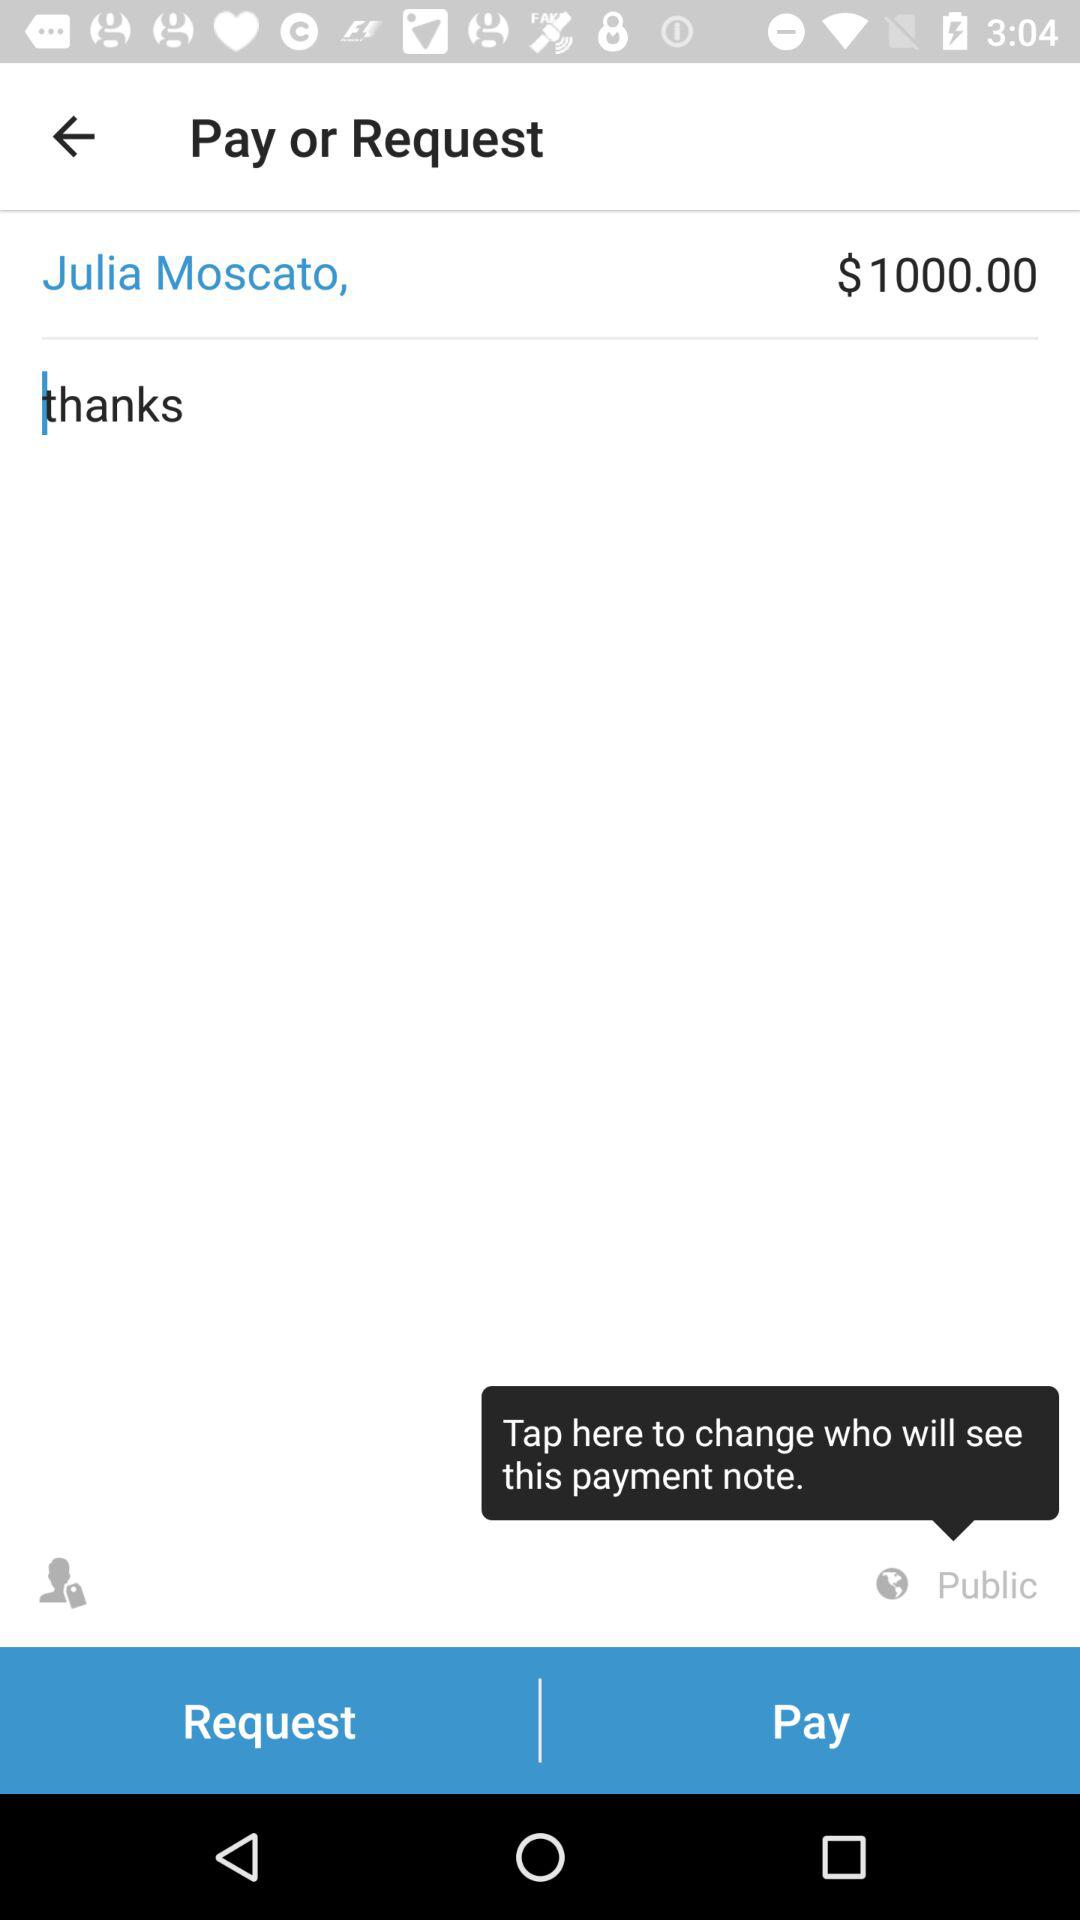What is the name of the person to whom the person wants to pay or request the money? The name of the person is Julia Moscato. 